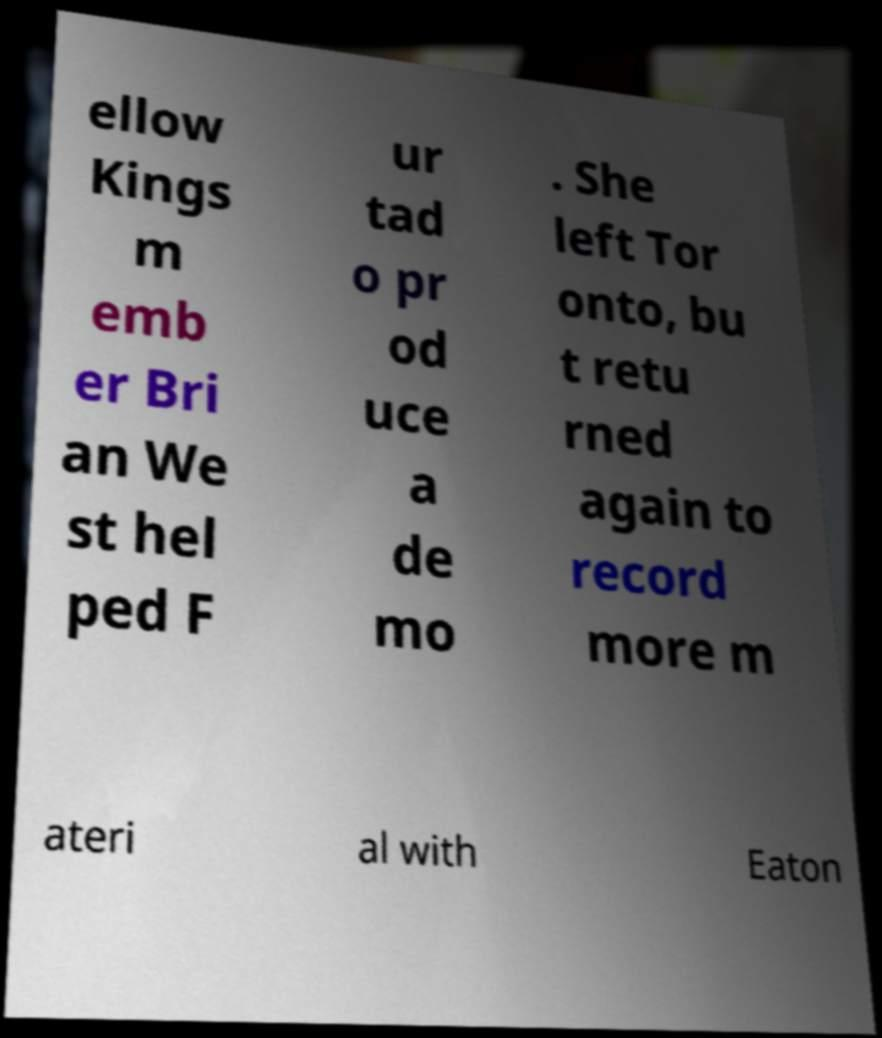For documentation purposes, I need the text within this image transcribed. Could you provide that? ellow Kings m emb er Bri an We st hel ped F ur tad o pr od uce a de mo . She left Tor onto, bu t retu rned again to record more m ateri al with Eaton 